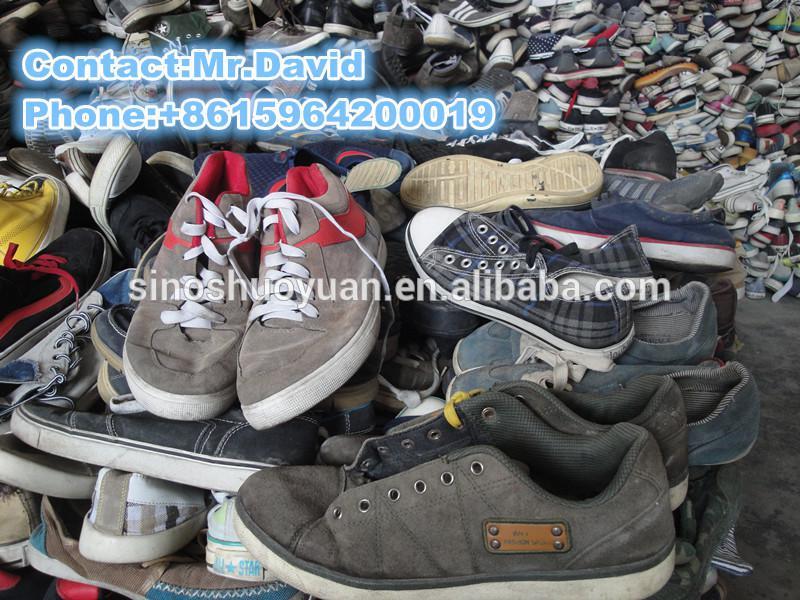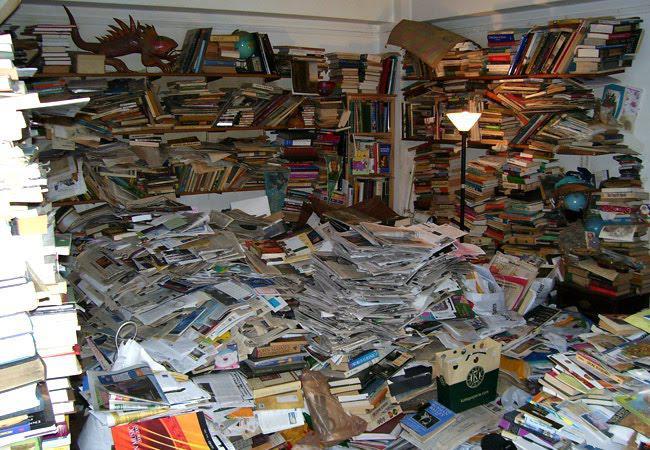The first image is the image on the left, the second image is the image on the right. Given the left and right images, does the statement "The shoes are displayed horizontally on the wall in the image on the right." hold true? Answer yes or no. No. 